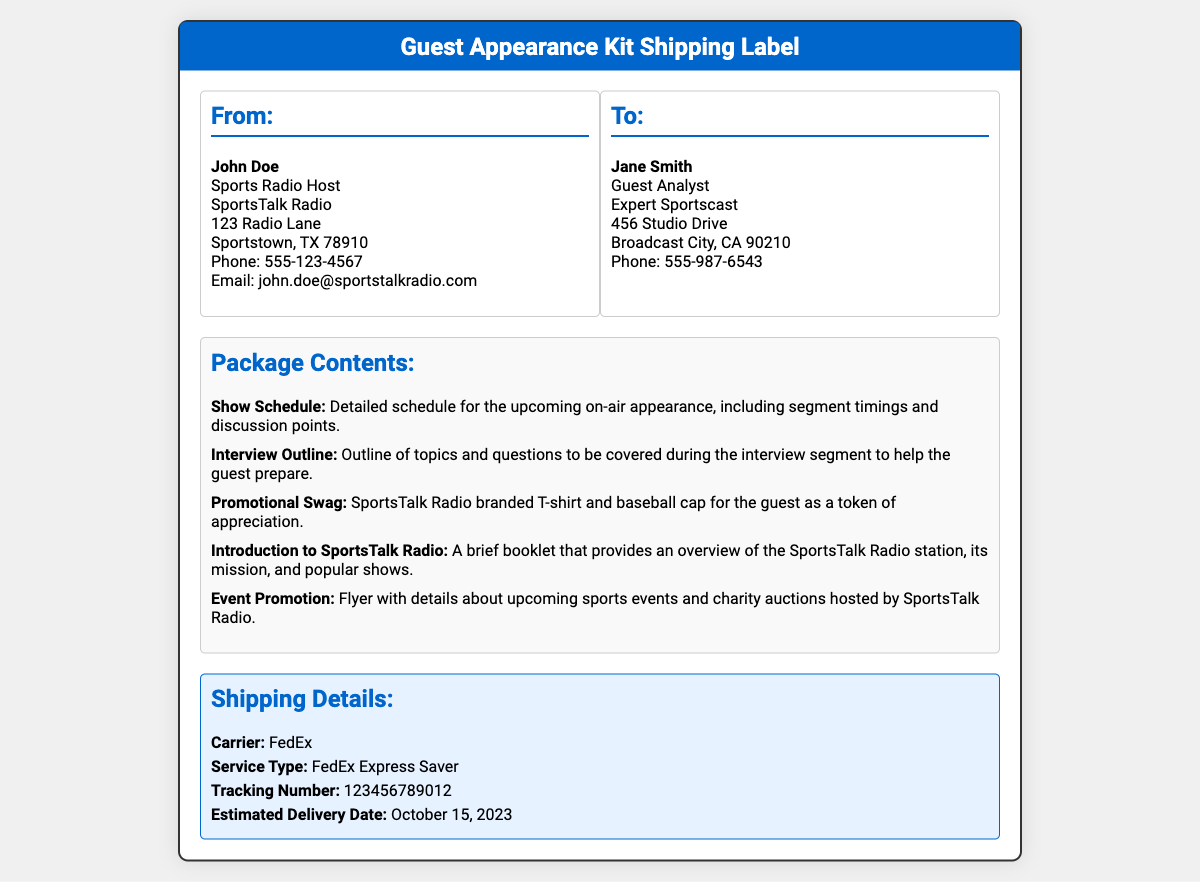what is the name of the sender? The sender's name is listed in the "From" section of the address, which is John Doe.
Answer: John Doe what is the delivery date? The estimated delivery date is mentioned in the shipping details section of the document as October 15, 2023.
Answer: October 15, 2023 who is the recipient? The recipient's name is listed in the "To" section of the address, which is Jane Smith.
Answer: Jane Smith what carrier is used for shipping? The document specifies the shipping carrier in the shipping details section, which is FedEx.
Answer: FedEx how many items are listed in the package contents? The number of items can be counted from the bullet points in the package contents section, which lists five.
Answer: Five what type of item is included as promotional swag? The package contents mention specific promotional swag items; one example is a sports radio branded T-shirt.
Answer: T-shirt what is included in the interview outline? The interview outline is focused on topics and questions to help the guest prepare.
Answer: Topics and questions what is the service type mentioned for shipping? The document lists the service type in the shipping details section, which is FedEx Express Saver.
Answer: FedEx Express Saver what document provides an overview of the SportsTalk Radio station? The package contents include a brief booklet that serves this purpose.
Answer: A brief booklet 